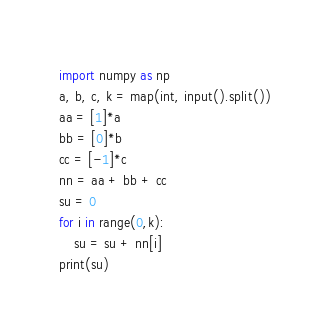<code> <loc_0><loc_0><loc_500><loc_500><_Python_>import numpy as np
a, b, c, k = map(int, input().split())
aa = [1]*a
bb = [0]*b
cc = [-1]*c
nn = aa + bb + cc
su = 0
for i in range(0,k):
    su = su + nn[i]
print(su)</code> 